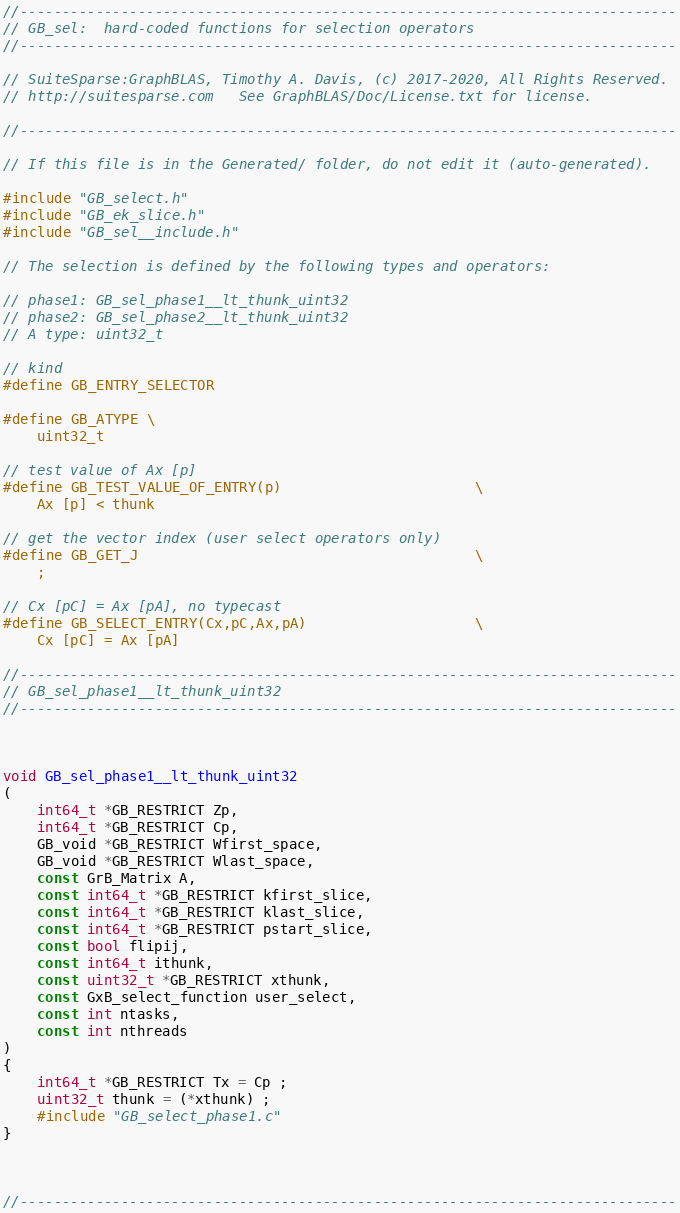Convert code to text. <code><loc_0><loc_0><loc_500><loc_500><_C_>//------------------------------------------------------------------------------
// GB_sel:  hard-coded functions for selection operators
//------------------------------------------------------------------------------

// SuiteSparse:GraphBLAS, Timothy A. Davis, (c) 2017-2020, All Rights Reserved.
// http://suitesparse.com   See GraphBLAS/Doc/License.txt for license.

//------------------------------------------------------------------------------

// If this file is in the Generated/ folder, do not edit it (auto-generated).

#include "GB_select.h"
#include "GB_ek_slice.h"
#include "GB_sel__include.h"

// The selection is defined by the following types and operators:

// phase1: GB_sel_phase1__lt_thunk_uint32
// phase2: GB_sel_phase2__lt_thunk_uint32
// A type: uint32_t

// kind
#define GB_ENTRY_SELECTOR

#define GB_ATYPE \
    uint32_t

// test value of Ax [p]
#define GB_TEST_VALUE_OF_ENTRY(p)                       \
    Ax [p] < thunk

// get the vector index (user select operators only)
#define GB_GET_J                                        \
    ;

// Cx [pC] = Ax [pA], no typecast
#define GB_SELECT_ENTRY(Cx,pC,Ax,pA)                    \
    Cx [pC] = Ax [pA]

//------------------------------------------------------------------------------
// GB_sel_phase1__lt_thunk_uint32
//------------------------------------------------------------------------------



void GB_sel_phase1__lt_thunk_uint32
(
    int64_t *GB_RESTRICT Zp,
    int64_t *GB_RESTRICT Cp,
    GB_void *GB_RESTRICT Wfirst_space,
    GB_void *GB_RESTRICT Wlast_space,
    const GrB_Matrix A,
    const int64_t *GB_RESTRICT kfirst_slice,
    const int64_t *GB_RESTRICT klast_slice,
    const int64_t *GB_RESTRICT pstart_slice,
    const bool flipij,
    const int64_t ithunk,
    const uint32_t *GB_RESTRICT xthunk,
    const GxB_select_function user_select,
    const int ntasks,
    const int nthreads
)
{ 
    int64_t *GB_RESTRICT Tx = Cp ;
    uint32_t thunk = (*xthunk) ;
    #include "GB_select_phase1.c"
}



//------------------------------------------------------------------------------</code> 